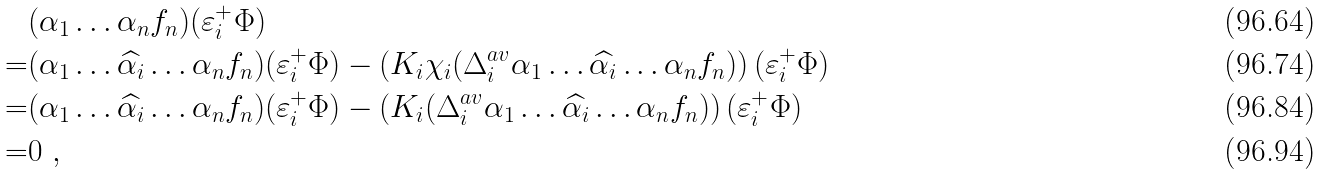<formula> <loc_0><loc_0><loc_500><loc_500>& ( \alpha _ { 1 } \dots \alpha _ { n } f _ { n } ) ( \varepsilon _ { i } ^ { + } \Phi ) \\ = & ( \alpha _ { 1 } \dots \widehat { \alpha _ { i } } \dots \alpha _ { n } f _ { n } ) ( \varepsilon _ { i } ^ { + } \Phi ) - \left ( K _ { i } \chi _ { i } ( \Delta ^ { a v } _ { i } \alpha _ { 1 } \dots \widehat { \alpha _ { i } } \dots \alpha _ { n } f _ { n } ) \right ) ( \varepsilon _ { i } ^ { + } \Phi ) \\ = & ( \alpha _ { 1 } \dots \widehat { \alpha _ { i } } \dots \alpha _ { n } f _ { n } ) ( \varepsilon _ { i } ^ { + } \Phi ) - \left ( K _ { i } ( \Delta ^ { a v } _ { i } \alpha _ { 1 } \dots \widehat { \alpha _ { i } } \dots \alpha _ { n } f _ { n } ) \right ) ( \varepsilon _ { i } ^ { + } \Phi ) \\ = & 0 \ ,</formula> 